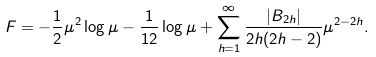<formula> <loc_0><loc_0><loc_500><loc_500>F = - \frac { 1 } { 2 } \mu ^ { 2 } \log \mu - \frac { 1 } { 1 2 } \log \mu + \sum _ { h = 1 } ^ { \infty } \frac { \left | B _ { 2 h } \right | } { 2 h ( 2 h - 2 ) } \mu ^ { 2 - 2 h } .</formula> 